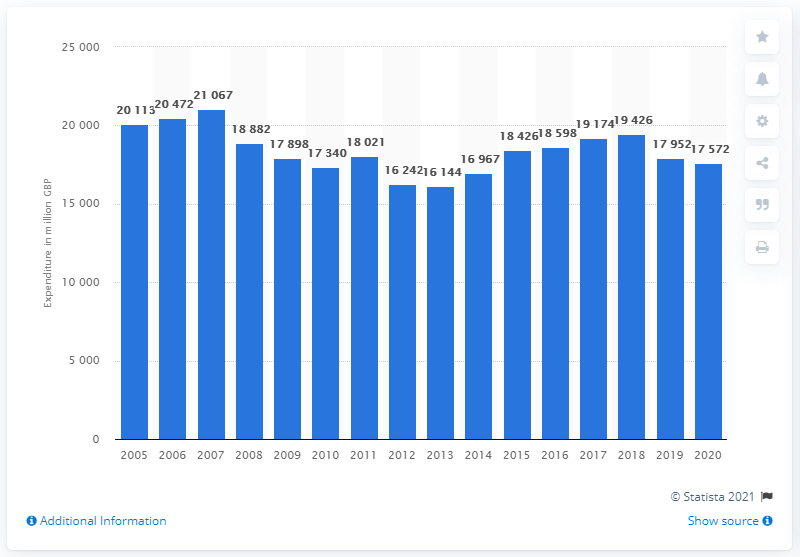Highlight a few significant elements in this photo. In the year 2020, households in the United Kingdom spent a total of 17,572 on furniture and floor coverings. 